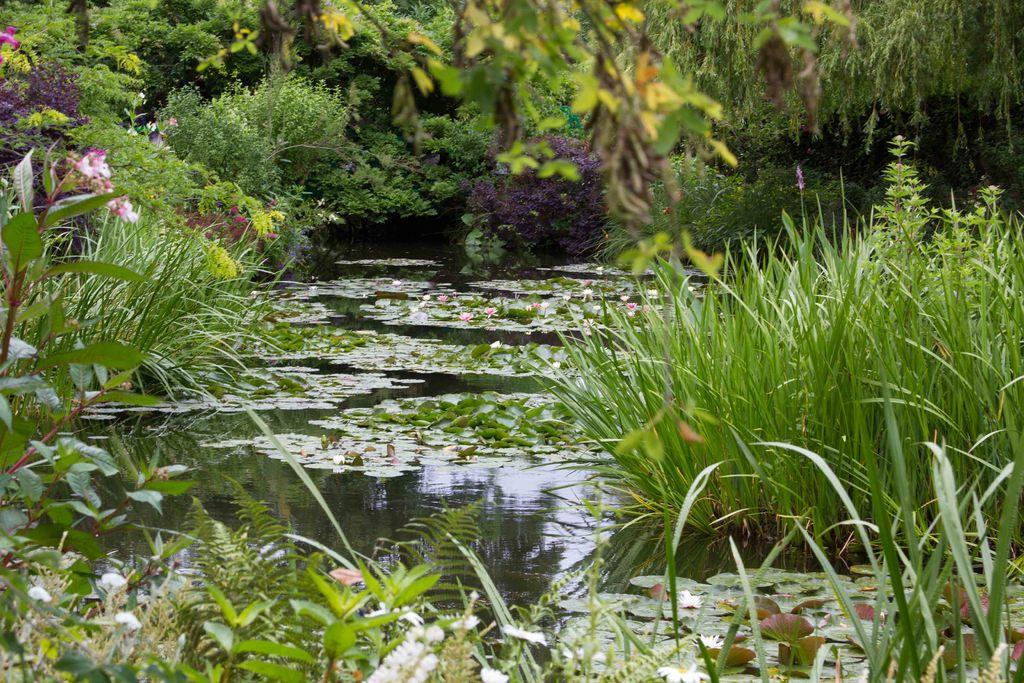What is the primary element visible in the image? There is water in the image. What is floating on the water? There are leaves on the water. What type of vegetation is present at the bottom of the image? There is grass and plants at the bottom of the image. What can be seen in the background of the image? There are trees in the background of the image. What type of flora is visible in the image? There are flowers visible in the image. How many rabbits can be seen taking a voyage on the water in the image? There are no rabbits visible in the image, and they are not taking a voyage on the water. What type of wave can be seen crashing into the shore in the image? There is no wave crashing into the shore in the image; it is a still body of water with leaves floating on it. 